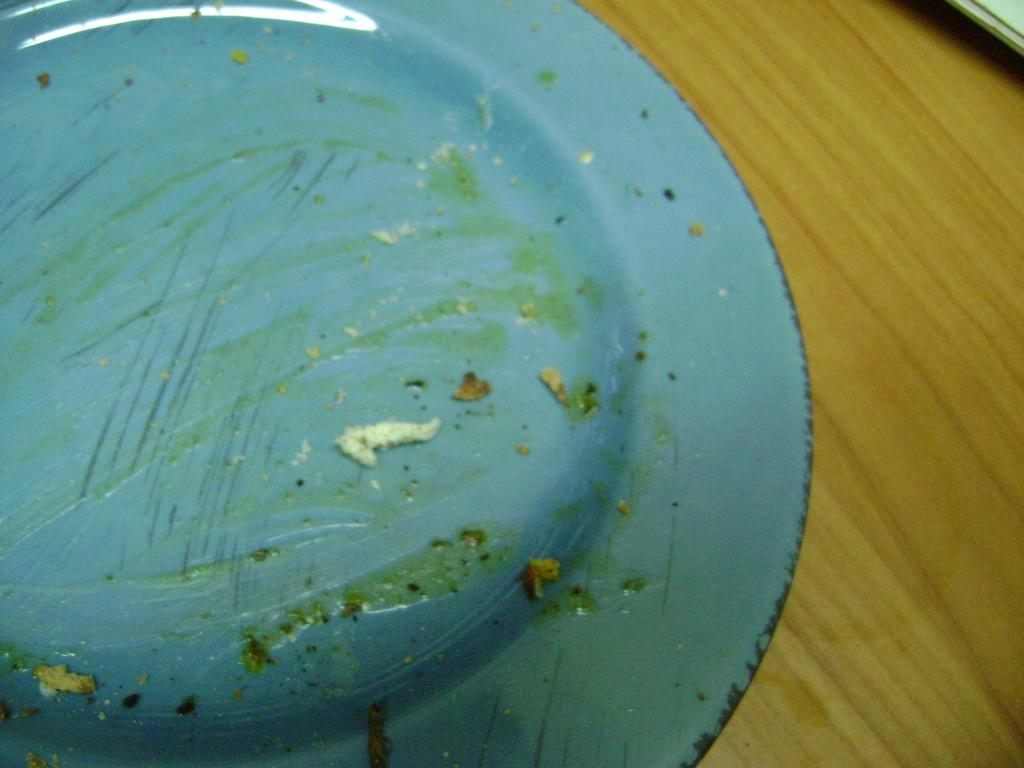What color is the plate in the image? The plate in the image is blue. How is the plate positioned on the table? The plate is placed in reverse position. What type of table is in the image? There is a wooden table in the image. How many chairs are visible in the bedroom in the image? There is no bedroom or chairs present in the image; it only features a blue color plate and a wooden table. 